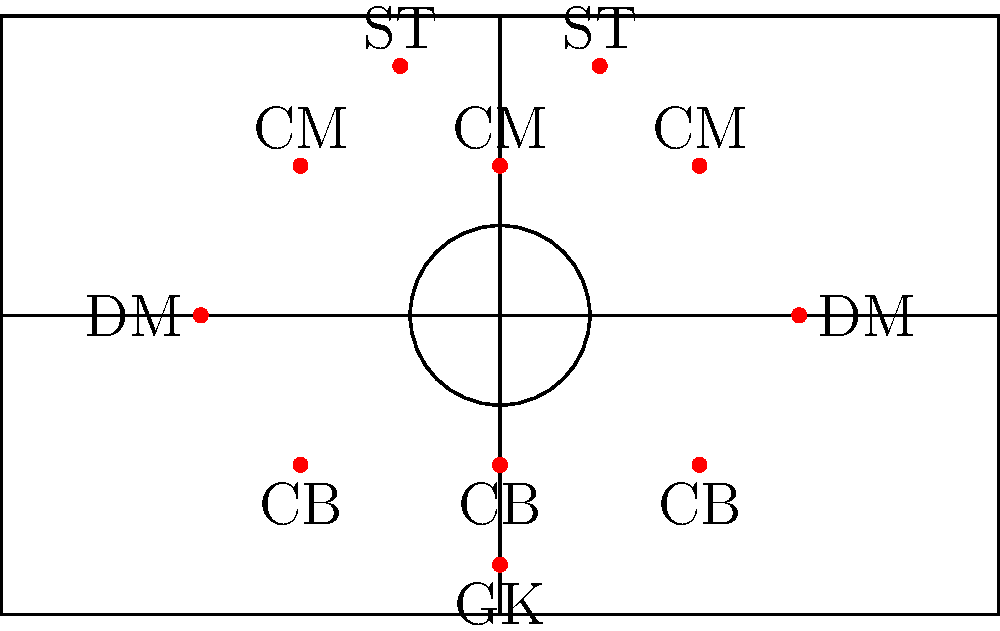In the given football formation diagram, which graph theory concept best represents the optimal passing network between players to maintain possession and create scoring opportunities? To analyze the optimal passing network in this formation, we can apply the concept of a weighted graph, where:

1. Each player position represents a node in the graph.
2. Potential passes between players are represented by edges.
3. The weight of each edge could represent factors like:
   - Distance between players
   - Difficulty of the pass
   - Defensive pressure in that area

To find the optimal passing network, we need to consider:

1. Minimum Spanning Tree (MST):
   - This would represent the most efficient way to connect all players with the minimum total "cost" of passes.
   - However, this might not capture all important passing options.

2. Complete Graph:
   - This would represent all possible passes between players.
   - While comprehensive, it's not realistic as not all passes are equally viable.

3. Planar Graph:
   - This better represents the actual layout on the pitch.
   - It avoids unrealistic long-distance passes that would cross over multiple players.

4. Maximum Flow:
   - This concept can be applied to model the flow of the ball from defense to attack.
   - The source would be the goalkeeper, and the sink would be the goal.

Considering these factors, the most appropriate graph theory concept for this formation is a planar weighted graph. This allows for:

- Realistic representation of the pitch layout
- Consideration of pass difficulty and defensive pressure
- Flexibility to include key long passes without overwhelming complexity

Using this planar weighted graph, we can then apply algorithms like Dijkstra's to find the most efficient passing routes from defense to attack, or between any two players.
Answer: Planar weighted graph 